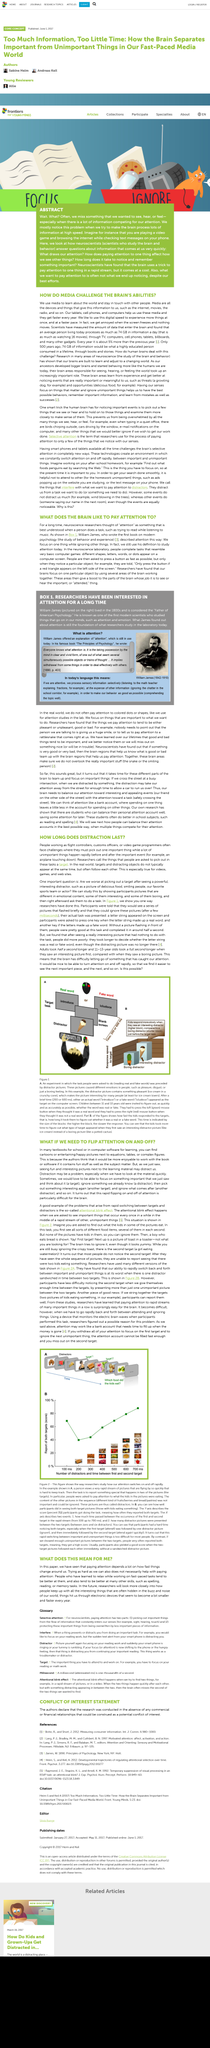Highlight a few significant elements in this photo. Three professions that are necessary for selecting targets are flight controllers, customs officers, and video game programmers. People who have learned to relax are better at fast-paced tasks compared to those who have not learned to relax. It is referred to as a target, the things that people are asked to pick out in a task. It is not true that trying hard will necessarily increase attention. In fact, trying hard may not have any effect on attention. The act of paying attention is dependent upon the rate at which things change around us. 